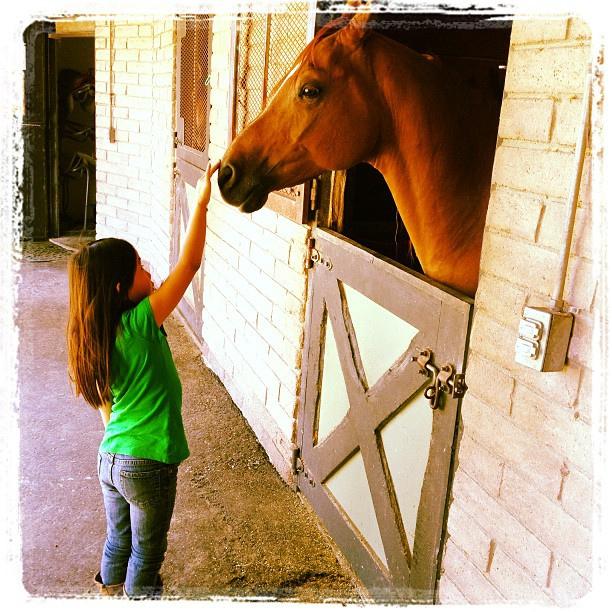What animal is the girl petting?
Be succinct. Horse. What color shirt is the girl wearing?
Quick response, please. Green. What is the little girl petting?
Quick response, please. Horse. 